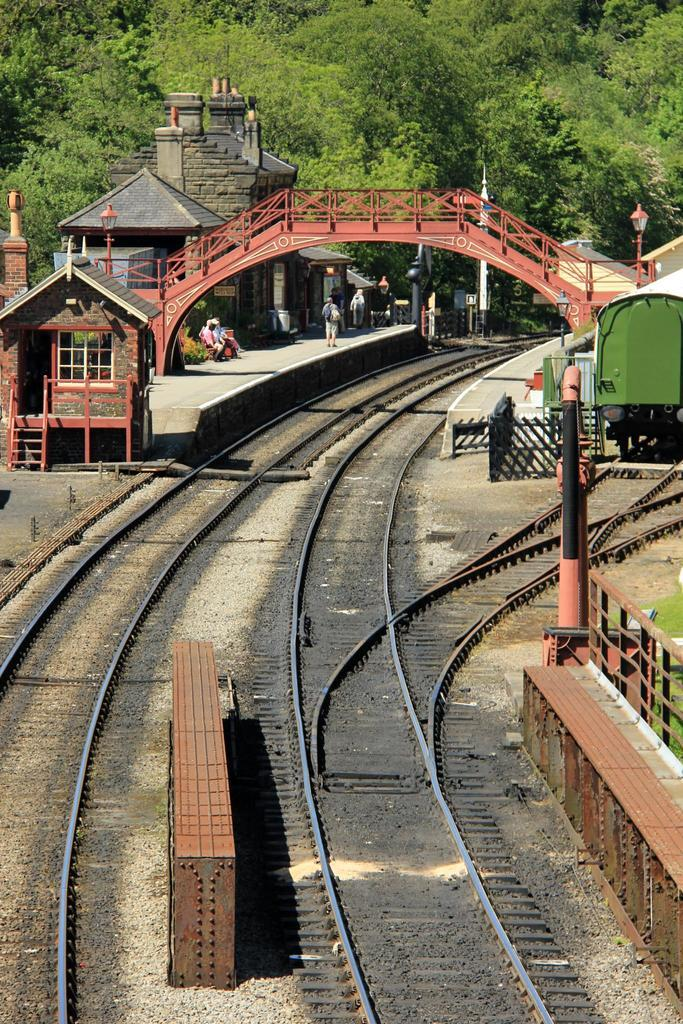What type of transportation infrastructure is visible in the image? There are railway tracks in the image. What structure is present over the railway tracks? There is a bridge in the image. What is located near the railway tracks? There is a platform in the image. What can be seen on the right side of the image? There is a train on the right side of the image. What type of natural scenery is visible in the background of the image? There are trees in the background of the image. What type of error can be seen in the image? There is no error present in the image. What type of trousers are the trees wearing in the image? Trees do not wear trousers, as they are living organisms and not human beings. 